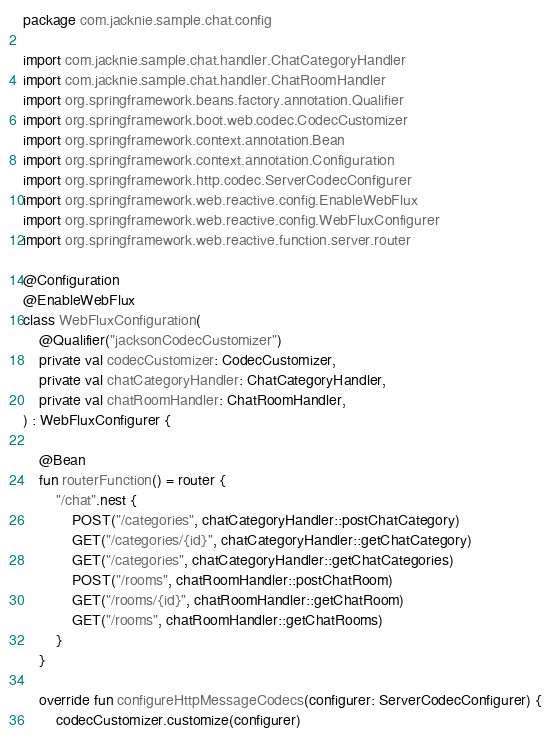<code> <loc_0><loc_0><loc_500><loc_500><_Kotlin_>package com.jacknie.sample.chat.config

import com.jacknie.sample.chat.handler.ChatCategoryHandler
import com.jacknie.sample.chat.handler.ChatRoomHandler
import org.springframework.beans.factory.annotation.Qualifier
import org.springframework.boot.web.codec.CodecCustomizer
import org.springframework.context.annotation.Bean
import org.springframework.context.annotation.Configuration
import org.springframework.http.codec.ServerCodecConfigurer
import org.springframework.web.reactive.config.EnableWebFlux
import org.springframework.web.reactive.config.WebFluxConfigurer
import org.springframework.web.reactive.function.server.router

@Configuration
@EnableWebFlux
class WebFluxConfiguration(
    @Qualifier("jacksonCodecCustomizer")
    private val codecCustomizer: CodecCustomizer,
    private val chatCategoryHandler: ChatCategoryHandler,
    private val chatRoomHandler: ChatRoomHandler,
) : WebFluxConfigurer {

    @Bean
    fun routerFunction() = router {
        "/chat".nest {
            POST("/categories", chatCategoryHandler::postChatCategory)
            GET("/categories/{id}", chatCategoryHandler::getChatCategory)
            GET("/categories", chatCategoryHandler::getChatCategories)
            POST("/rooms", chatRoomHandler::postChatRoom)
            GET("/rooms/{id}", chatRoomHandler::getChatRoom)
            GET("/rooms", chatRoomHandler::getChatRooms)
        }
    }

    override fun configureHttpMessageCodecs(configurer: ServerCodecConfigurer) {
        codecCustomizer.customize(configurer)</code> 